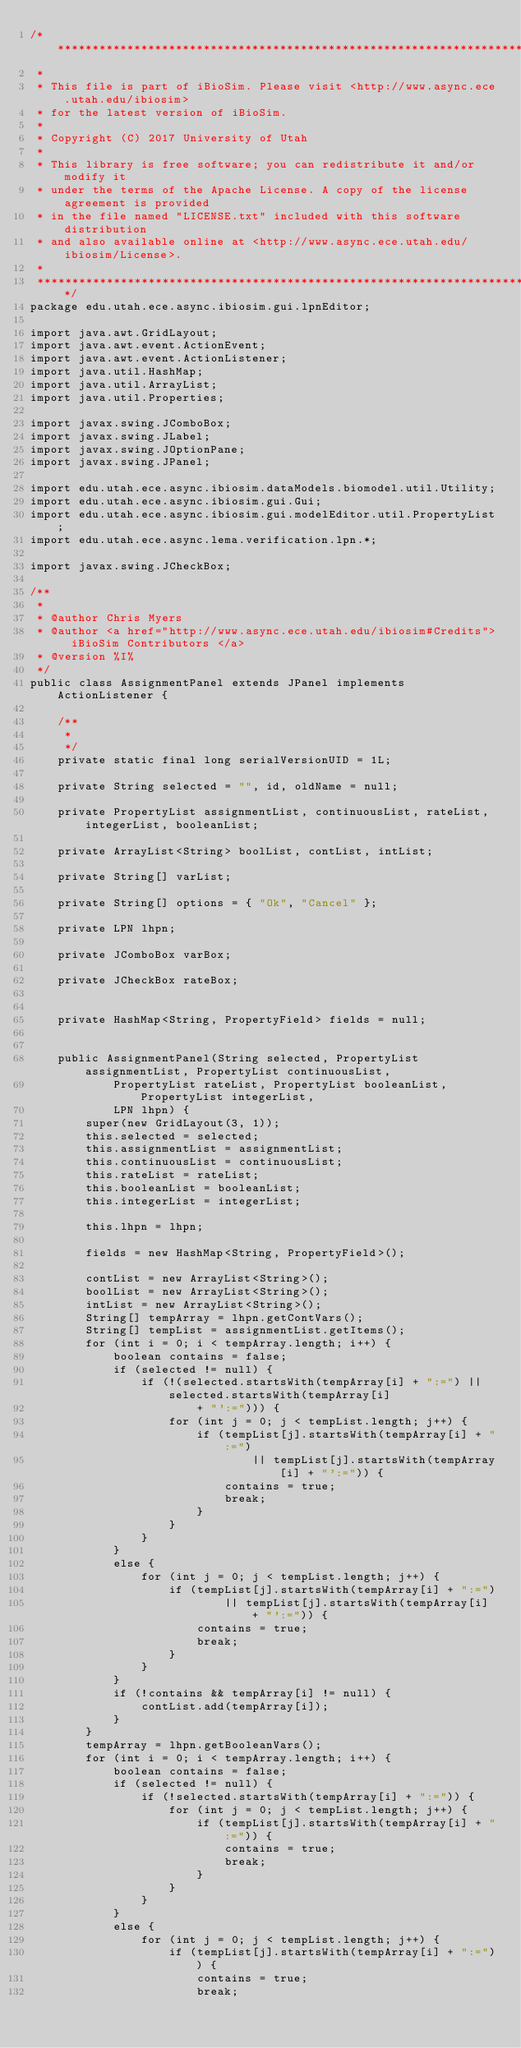Convert code to text. <code><loc_0><loc_0><loc_500><loc_500><_Java_>/*******************************************************************************
 *  
 * This file is part of iBioSim. Please visit <http://www.async.ece.utah.edu/ibiosim>
 * for the latest version of iBioSim.
 *
 * Copyright (C) 2017 University of Utah
 *
 * This library is free software; you can redistribute it and/or modify it
 * under the terms of the Apache License. A copy of the license agreement is provided
 * in the file named "LICENSE.txt" included with this software distribution
 * and also available online at <http://www.async.ece.utah.edu/ibiosim/License>.
 *  
 *******************************************************************************/
package edu.utah.ece.async.ibiosim.gui.lpnEditor;

import java.awt.GridLayout;
import java.awt.event.ActionEvent;
import java.awt.event.ActionListener;
import java.util.HashMap;
import java.util.ArrayList;
import java.util.Properties;

import javax.swing.JComboBox;
import javax.swing.JLabel;
import javax.swing.JOptionPane;
import javax.swing.JPanel;

import edu.utah.ece.async.ibiosim.dataModels.biomodel.util.Utility;
import edu.utah.ece.async.ibiosim.gui.Gui;
import edu.utah.ece.async.ibiosim.gui.modelEditor.util.PropertyList;
import edu.utah.ece.async.lema.verification.lpn.*;

import javax.swing.JCheckBox;

/**
 * 
 * @author Chris Myers
 * @author <a href="http://www.async.ece.utah.edu/ibiosim#Credits"> iBioSim Contributors </a>
 * @version %I%
 */
public class AssignmentPanel extends JPanel implements ActionListener {

	/**
	 * 
	 */
	private static final long serialVersionUID = 1L;

	private String selected = "", id, oldName = null;

	private PropertyList assignmentList, continuousList, rateList, integerList, booleanList;

	private ArrayList<String> boolList, contList, intList;

	private String[] varList;

	private String[] options = { "Ok", "Cancel" };

	private LPN lhpn;

	private JComboBox varBox;

	private JCheckBox rateBox;


	private HashMap<String, PropertyField> fields = null;


	public AssignmentPanel(String selected, PropertyList assignmentList, PropertyList continuousList,
			PropertyList rateList, PropertyList booleanList, PropertyList integerList,
			LPN lhpn) {
		super(new GridLayout(3, 1));
		this.selected = selected;
		this.assignmentList = assignmentList;
		this.continuousList = continuousList;
		this.rateList = rateList;
		this.booleanList = booleanList;
		this.integerList = integerList;

		this.lhpn = lhpn;

		fields = new HashMap<String, PropertyField>();

		contList = new ArrayList<String>();
		boolList = new ArrayList<String>();
		intList = new ArrayList<String>();
		String[] tempArray = lhpn.getContVars();
		String[] tempList = assignmentList.getItems();
		for (int i = 0; i < tempArray.length; i++) {
			boolean contains = false;
			if (selected != null) {
				if (!(selected.startsWith(tempArray[i] + ":=") || selected.startsWith(tempArray[i]
						+ "':="))) {
					for (int j = 0; j < tempList.length; j++) {
						if (tempList[j].startsWith(tempArray[i] + ":=")
								|| tempList[j].startsWith(tempArray[i] + "':=")) {
							contains = true;
							break;
						}
					}
				}
			}
			else {
				for (int j = 0; j < tempList.length; j++) {
					if (tempList[j].startsWith(tempArray[i] + ":=")
							|| tempList[j].startsWith(tempArray[i] + "':=")) {
						contains = true;
						break;
					}
				}
			}
			if (!contains && tempArray[i] != null) {
				contList.add(tempArray[i]);
			}
		}
		tempArray = lhpn.getBooleanVars();
		for (int i = 0; i < tempArray.length; i++) {
			boolean contains = false;
			if (selected != null) {
				if (!selected.startsWith(tempArray[i] + ":=")) {
					for (int j = 0; j < tempList.length; j++) {
						if (tempList[j].startsWith(tempArray[i] + ":=")) {
							contains = true;
							break;
						}
					}
				}
			}
			else {
				for (int j = 0; j < tempList.length; j++) {
					if (tempList[j].startsWith(tempArray[i] + ":=")) {
						contains = true;
						break;</code> 